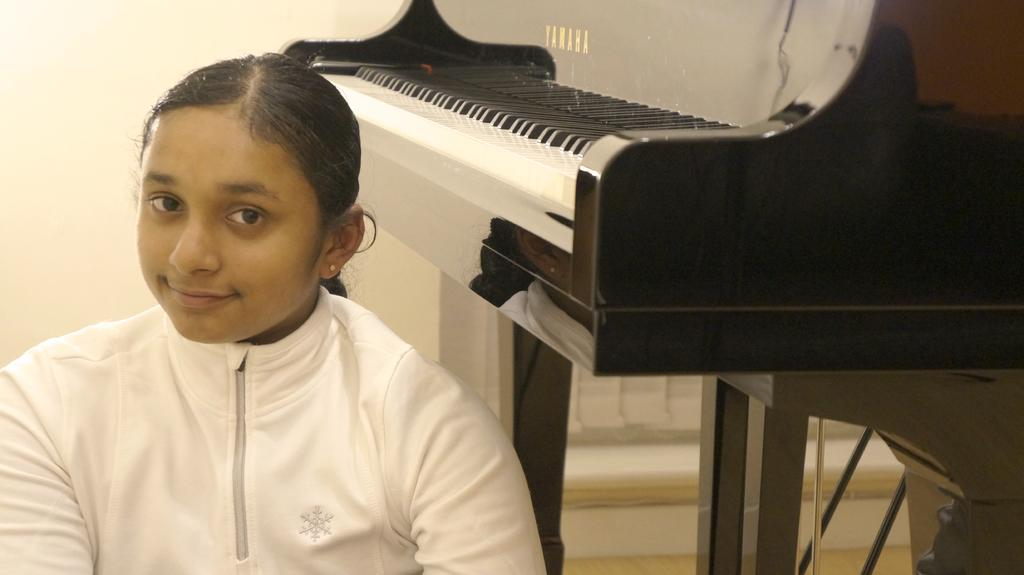Who is the main subject in the image? There is a girl in the image. What is the girl doing in the image? The girl is smiling. What is the girl wearing in the image? The girl is wearing a white jacket. What can be seen in the background of the image? There is a piano in the background of the image. What type of ray is visible in the image? There is no ray present in the image. What sound does the girl make while playing the piano in the image? The image does not show the girl playing the piano, so it is not possible to determine the sound she might make. 